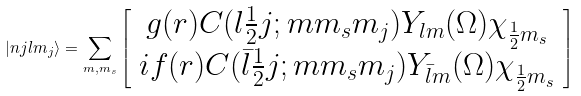<formula> <loc_0><loc_0><loc_500><loc_500>| n j l m _ { j } \rangle = \sum _ { m , m _ { s } } \left [ \begin{array} { c } g ( r ) C ( l \frac { 1 } { 2 } j ; m m _ { s } m _ { j } ) Y _ { l m } ( \Omega ) \chi _ { \frac { 1 } { 2 } m _ { s } } \\ i f ( r ) C ( \bar { l } \frac { 1 } { 2 } j ; m m _ { s } m _ { j } ) Y _ { \bar { l } m } ( \Omega ) \chi _ { \frac { 1 } { 2 } m _ { s } } \end{array} \right ]</formula> 